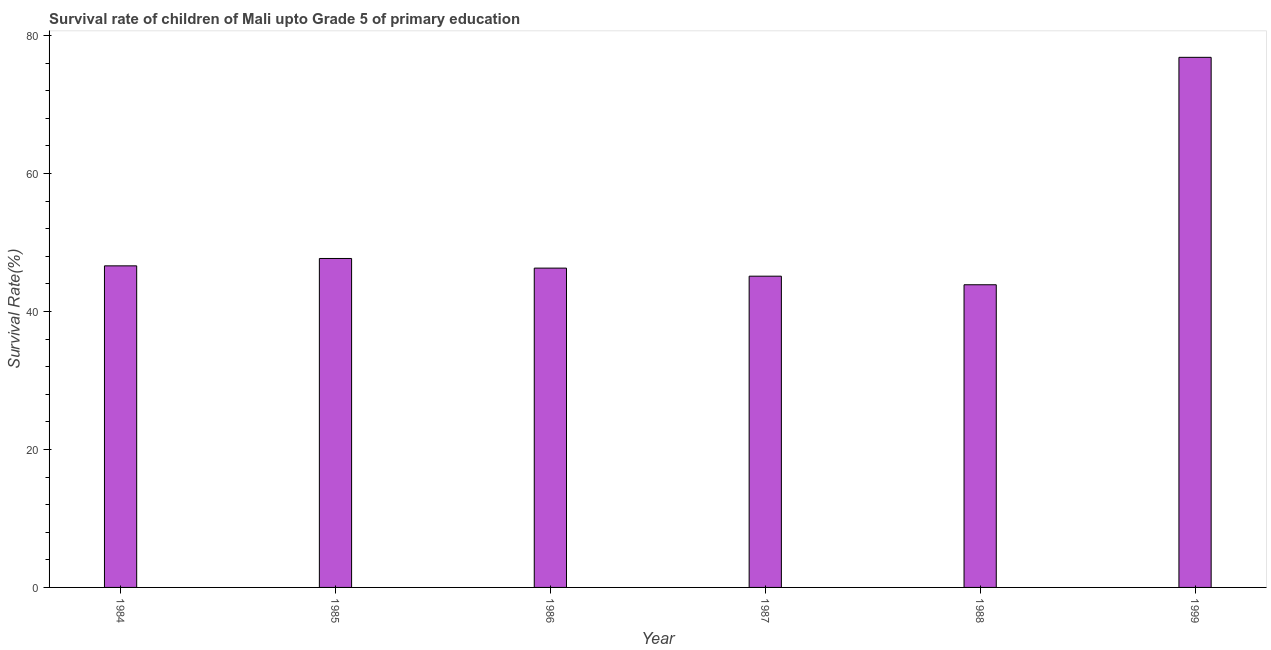What is the title of the graph?
Ensure brevity in your answer.  Survival rate of children of Mali upto Grade 5 of primary education. What is the label or title of the Y-axis?
Offer a terse response. Survival Rate(%). What is the survival rate in 1999?
Ensure brevity in your answer.  76.85. Across all years, what is the maximum survival rate?
Provide a succinct answer. 76.85. Across all years, what is the minimum survival rate?
Provide a short and direct response. 43.88. What is the sum of the survival rate?
Offer a terse response. 306.45. What is the difference between the survival rate in 1986 and 1988?
Make the answer very short. 2.41. What is the average survival rate per year?
Your answer should be very brief. 51.08. What is the median survival rate?
Give a very brief answer. 46.46. In how many years, is the survival rate greater than 64 %?
Provide a short and direct response. 1. Do a majority of the years between 1986 and 1987 (inclusive) have survival rate greater than 28 %?
Give a very brief answer. Yes. What is the ratio of the survival rate in 1986 to that in 1988?
Provide a short and direct response. 1.05. What is the difference between the highest and the second highest survival rate?
Your answer should be compact. 29.16. Is the sum of the survival rate in 1984 and 1985 greater than the maximum survival rate across all years?
Give a very brief answer. Yes. What is the difference between the highest and the lowest survival rate?
Offer a very short reply. 32.97. In how many years, is the survival rate greater than the average survival rate taken over all years?
Provide a succinct answer. 1. How many bars are there?
Keep it short and to the point. 6. What is the difference between two consecutive major ticks on the Y-axis?
Your answer should be compact. 20. What is the Survival Rate(%) in 1984?
Make the answer very short. 46.62. What is the Survival Rate(%) in 1985?
Your answer should be very brief. 47.69. What is the Survival Rate(%) of 1986?
Your answer should be compact. 46.29. What is the Survival Rate(%) of 1987?
Offer a very short reply. 45.12. What is the Survival Rate(%) in 1988?
Offer a very short reply. 43.88. What is the Survival Rate(%) in 1999?
Ensure brevity in your answer.  76.85. What is the difference between the Survival Rate(%) in 1984 and 1985?
Make the answer very short. -1.07. What is the difference between the Survival Rate(%) in 1984 and 1986?
Keep it short and to the point. 0.33. What is the difference between the Survival Rate(%) in 1984 and 1987?
Offer a terse response. 1.5. What is the difference between the Survival Rate(%) in 1984 and 1988?
Provide a succinct answer. 2.74. What is the difference between the Survival Rate(%) in 1984 and 1999?
Ensure brevity in your answer.  -30.23. What is the difference between the Survival Rate(%) in 1985 and 1986?
Your response must be concise. 1.4. What is the difference between the Survival Rate(%) in 1985 and 1987?
Keep it short and to the point. 2.57. What is the difference between the Survival Rate(%) in 1985 and 1988?
Provide a succinct answer. 3.81. What is the difference between the Survival Rate(%) in 1985 and 1999?
Offer a very short reply. -29.16. What is the difference between the Survival Rate(%) in 1986 and 1987?
Make the answer very short. 1.17. What is the difference between the Survival Rate(%) in 1986 and 1988?
Provide a succinct answer. 2.41. What is the difference between the Survival Rate(%) in 1986 and 1999?
Keep it short and to the point. -30.56. What is the difference between the Survival Rate(%) in 1987 and 1988?
Offer a terse response. 1.24. What is the difference between the Survival Rate(%) in 1987 and 1999?
Your answer should be very brief. -31.73. What is the difference between the Survival Rate(%) in 1988 and 1999?
Provide a succinct answer. -32.97. What is the ratio of the Survival Rate(%) in 1984 to that in 1985?
Offer a terse response. 0.98. What is the ratio of the Survival Rate(%) in 1984 to that in 1986?
Provide a succinct answer. 1.01. What is the ratio of the Survival Rate(%) in 1984 to that in 1987?
Offer a terse response. 1.03. What is the ratio of the Survival Rate(%) in 1984 to that in 1988?
Your answer should be very brief. 1.06. What is the ratio of the Survival Rate(%) in 1984 to that in 1999?
Provide a short and direct response. 0.61. What is the ratio of the Survival Rate(%) in 1985 to that in 1986?
Offer a terse response. 1.03. What is the ratio of the Survival Rate(%) in 1985 to that in 1987?
Your answer should be very brief. 1.06. What is the ratio of the Survival Rate(%) in 1985 to that in 1988?
Your answer should be very brief. 1.09. What is the ratio of the Survival Rate(%) in 1985 to that in 1999?
Give a very brief answer. 0.62. What is the ratio of the Survival Rate(%) in 1986 to that in 1988?
Your answer should be compact. 1.05. What is the ratio of the Survival Rate(%) in 1986 to that in 1999?
Provide a succinct answer. 0.6. What is the ratio of the Survival Rate(%) in 1987 to that in 1988?
Your response must be concise. 1.03. What is the ratio of the Survival Rate(%) in 1987 to that in 1999?
Make the answer very short. 0.59. What is the ratio of the Survival Rate(%) in 1988 to that in 1999?
Your answer should be very brief. 0.57. 